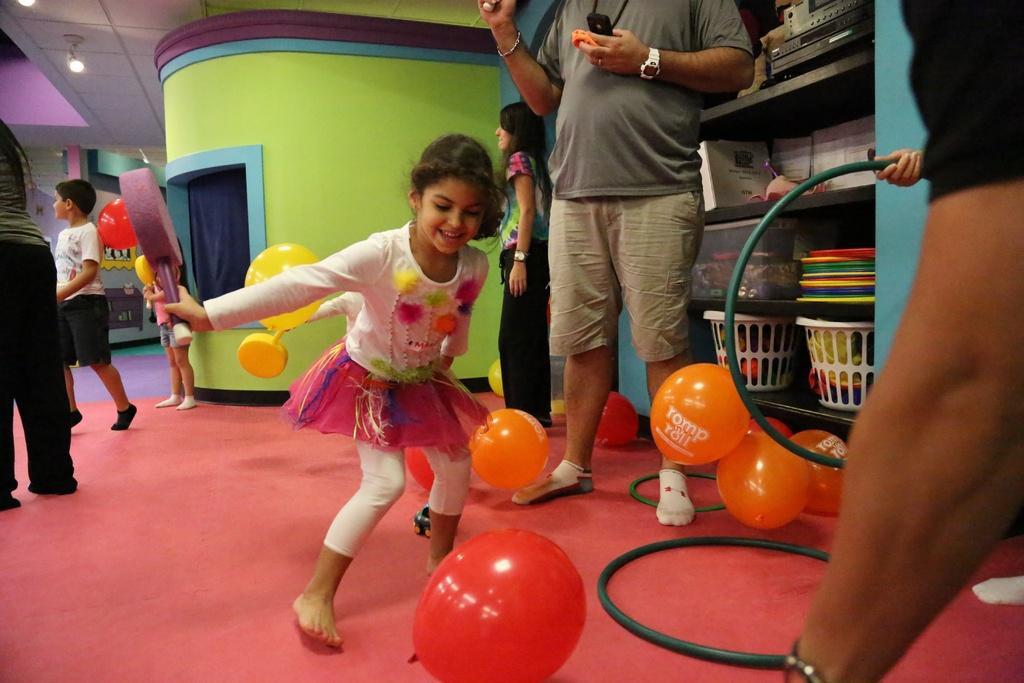Please provide a concise description of this image. Here in this picture in the middle we can see a child trying to play with the balloon present on the floor in front of her and we can see she is smiling and we can see other people and children also standing on the floor over there and we can also see other balloons also present and on the right side we can see a person holding a ring in hand and in the racks we can see baskets and bins present over there and we can see lights on the roof present over there. 